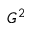<formula> <loc_0><loc_0><loc_500><loc_500>G ^ { 2 }</formula> 